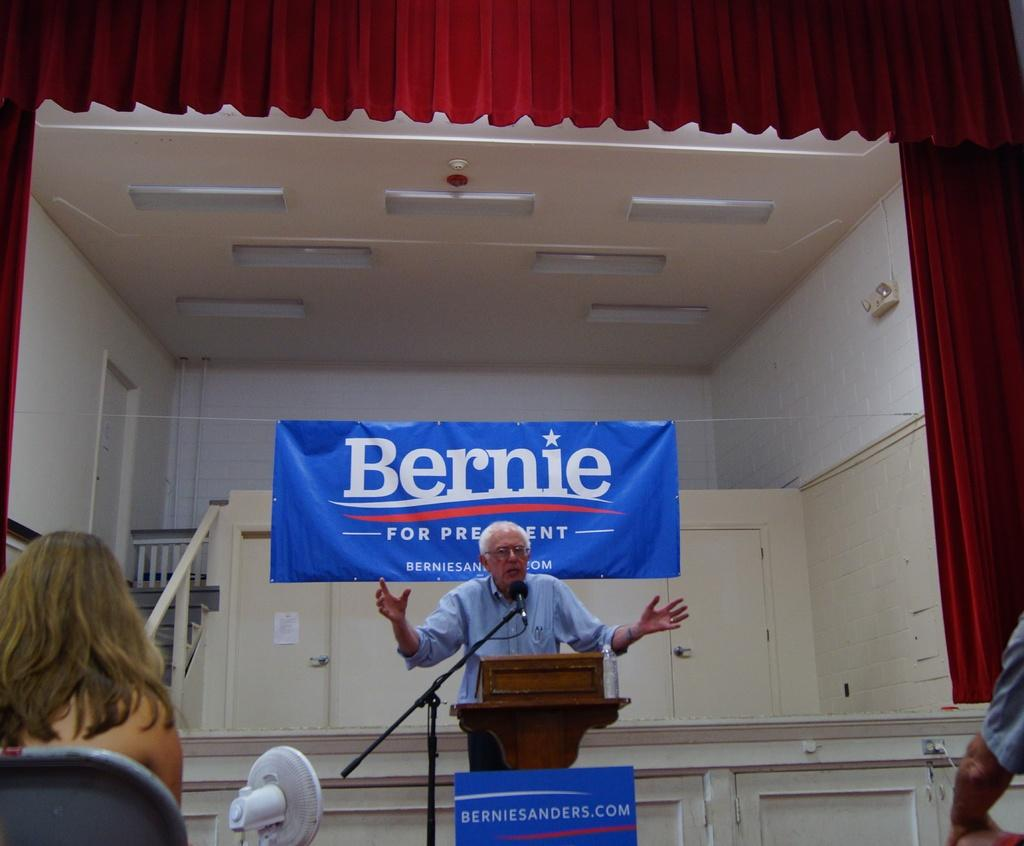What is the person in the image doing with the microphone? The person is standing with a microphone in the image and is talking. What are the people in the image doing? The people are sitting and listening in the image. What type of anger can be seen on the person's face while talking into the microphone? There is no indication of anger on the person's face in the image; they are simply talking into the microphone. What is the purpose of the mailbox in the image? There is no mailbox present in the image. 